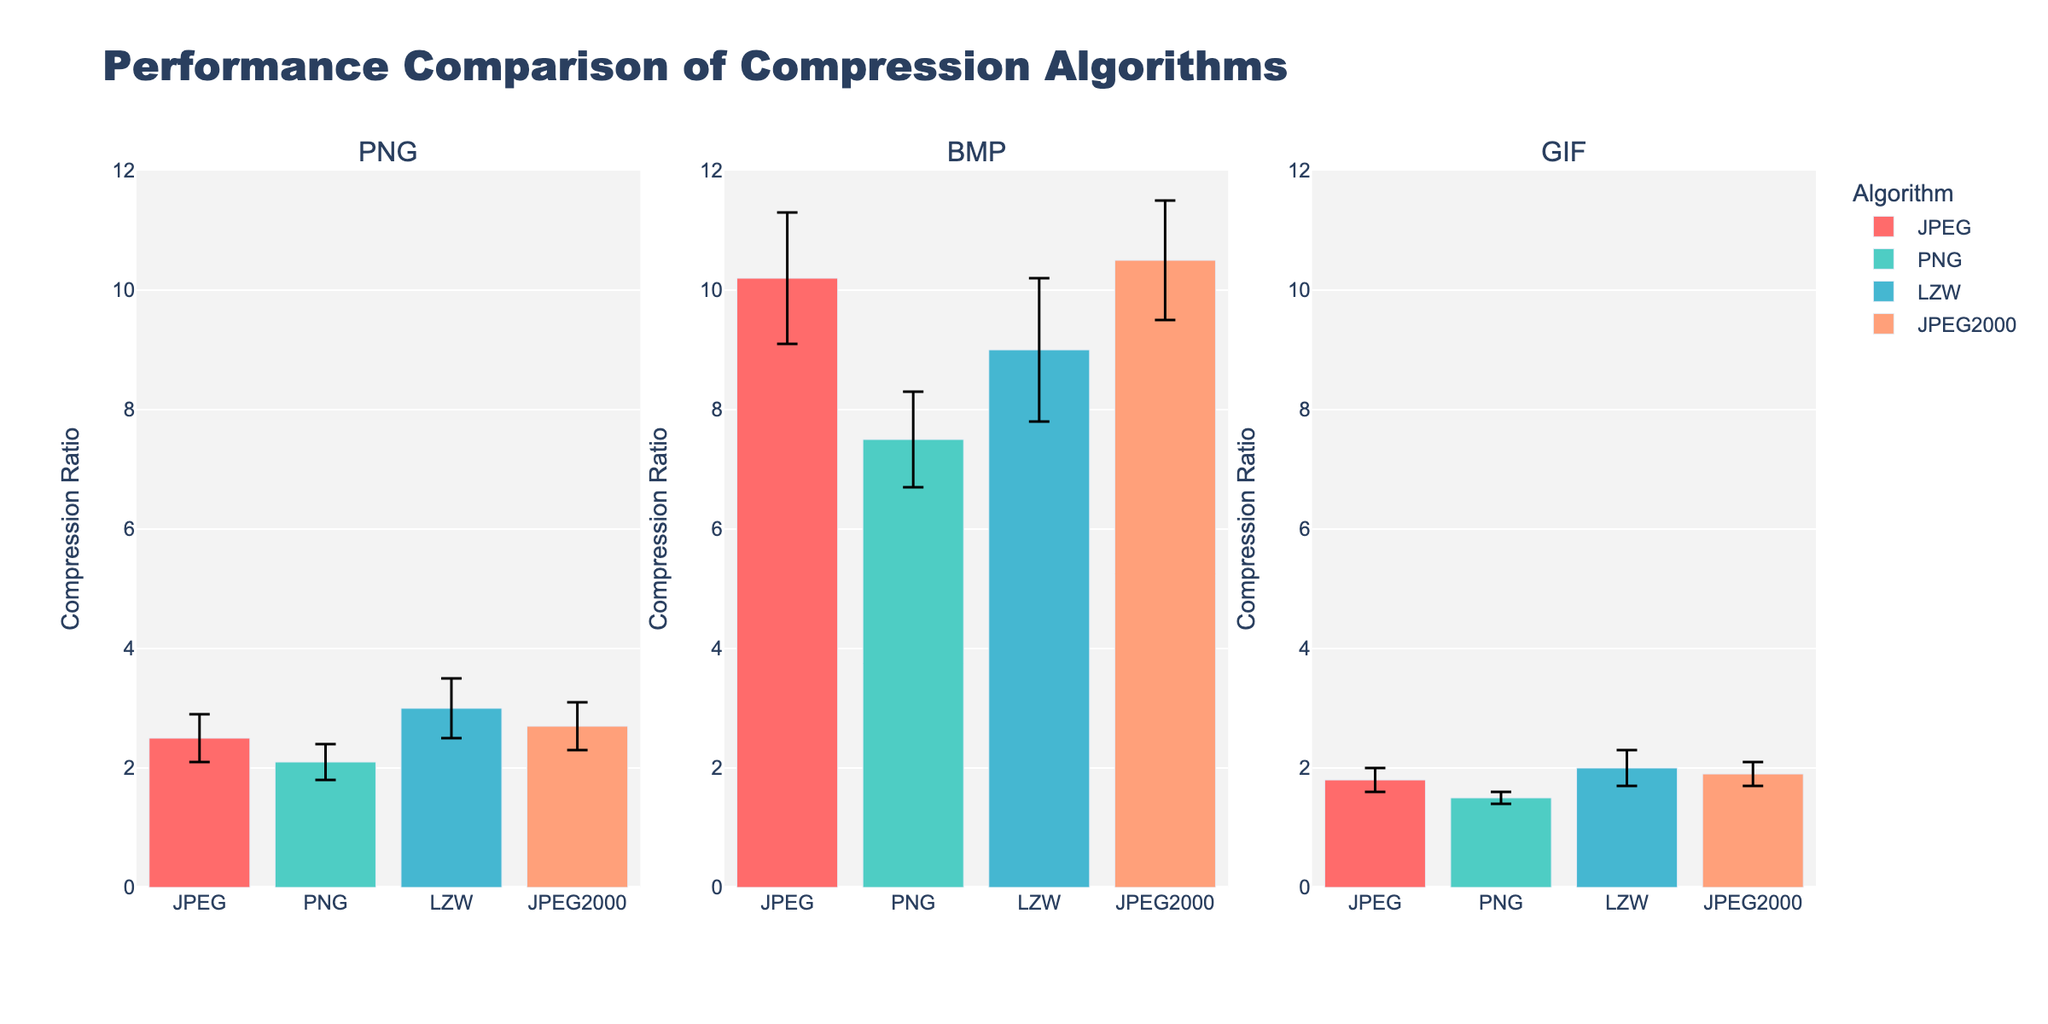what does the title of the bar chart indicate? The title of the bar chart reads as "Performance Comparison of Compression Algorithms," which indicates that the chart compares the performance of different compression algorithms based on their compression ratios for various image formats.
Answer: Performance Comparison of Compression Algorithms Which compression algorithm has the highest mean compression ratio for the BMP format? Observing the bar heights for the BMP format subplot, the bar representing the JPEG2000 algorithm is the highest.
Answer: JPEG2000 What is the mean compression ratio of the JPEG algorithm for the PNG image format? The height of the bar corresponding to the JPEG algorithm in the PNG image format subplot indicates the mean compression ratio.
Answer: 2.5 Which algorithm shows the least variation in compression ratio for the GIF format? The algorithm with the smallest error margin (shortest error bar) in the GIF subplot indicates the least variation, which is the PNG algorithm.
Answer: PNG How does the mean compression ratio of the PNG algorithm for the BMP format compare to that of the LZW algorithm for the same format? By comparing the bar heights in the BMP format subplot, the mean compression ratio of PNG is lower (7.5) than LZW (9.0).
Answer: PNG is lower than LZW What is the difference in mean compression ratios between the JPEG and LZW algorithms for the PNG format? Subtract the mean compression ratio of the LZW algorithm (3.0) from that of the JPEG algorithm (2.5) in the PNG format subplot.
Answer: 0.5 For the GIF format, which algorithm has the largest mean compression ratio, and by how much does it exceed the algorithm with the second-highest mean ratio? The JPEG algorithm has the highest mean ratio (1.8), and the LZW algorithm has the second-highest (2.0), so the difference is 0.2.
Answer: LZW by 0.2 What is common between the error margins of JPEG and JPEG2000 algorithms for the PNG format? The error bars of both JPEG and JPEG2000 algorithms are of the same length, indicating they have the same standard deviation of compression ratios.
Answer: Same standard deviation Which image format shows the greatest variation in mean compression ratios across all algorithms? By examining the lengths of the bars and error bars collectively across all subplots (PNG, BMP, GIF), the BMP format shows the largest spread (highest error margins).
Answer: BMP Given the bar colors in the legend, which algorithm corresponds to the red (or closest to red) color? The red (or closest to red) color in the legend symbolizes the JPEG algorithm.
Answer: JPEG 